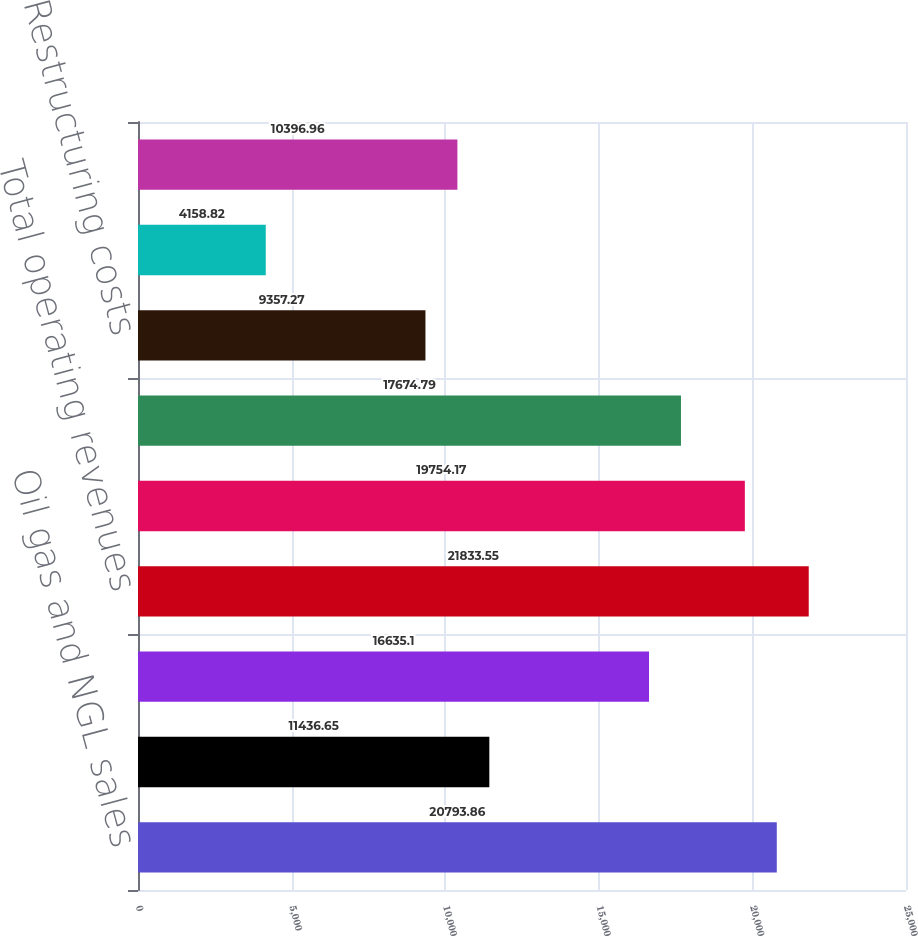Convert chart to OTSL. <chart><loc_0><loc_0><loc_500><loc_500><bar_chart><fcel>Oil gas and NGL sales<fcel>Oil gas and NGL derivatives<fcel>Marketing and midstream<fcel>Total operating revenues<fcel>Lease operating expenses<fcel>Asset impairments<fcel>Restructuring costs<fcel>Gains and losses on asset<fcel>Other operating items<nl><fcel>20793.9<fcel>11436.6<fcel>16635.1<fcel>21833.5<fcel>19754.2<fcel>17674.8<fcel>9357.27<fcel>4158.82<fcel>10397<nl></chart> 